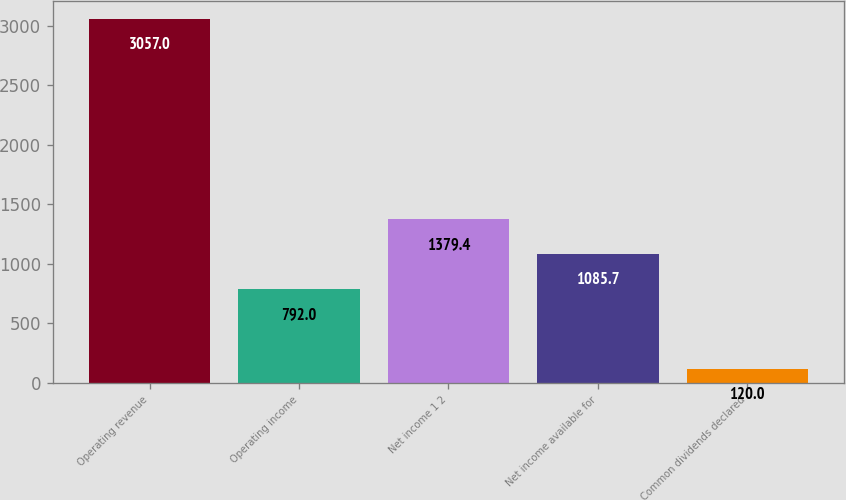Convert chart. <chart><loc_0><loc_0><loc_500><loc_500><bar_chart><fcel>Operating revenue<fcel>Operating income<fcel>Net income 1 2<fcel>Net income available for<fcel>Common dividends declared<nl><fcel>3057<fcel>792<fcel>1379.4<fcel>1085.7<fcel>120<nl></chart> 